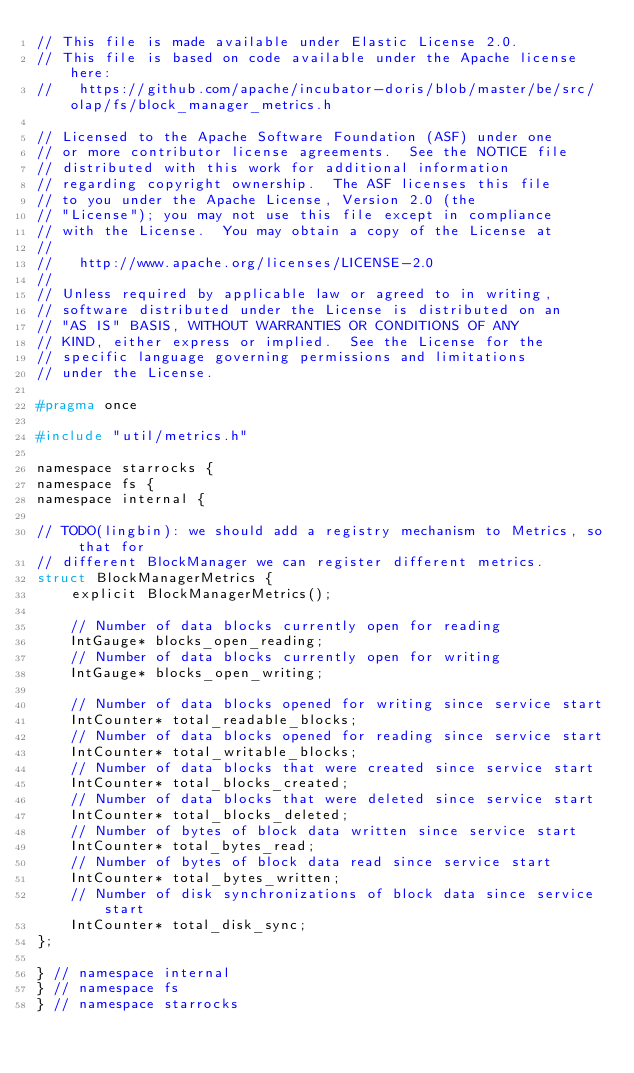<code> <loc_0><loc_0><loc_500><loc_500><_C_>// This file is made available under Elastic License 2.0.
// This file is based on code available under the Apache license here:
//   https://github.com/apache/incubator-doris/blob/master/be/src/olap/fs/block_manager_metrics.h

// Licensed to the Apache Software Foundation (ASF) under one
// or more contributor license agreements.  See the NOTICE file
// distributed with this work for additional information
// regarding copyright ownership.  The ASF licenses this file
// to you under the Apache License, Version 2.0 (the
// "License"); you may not use this file except in compliance
// with the License.  You may obtain a copy of the License at
//
//   http://www.apache.org/licenses/LICENSE-2.0
//
// Unless required by applicable law or agreed to in writing,
// software distributed under the License is distributed on an
// "AS IS" BASIS, WITHOUT WARRANTIES OR CONDITIONS OF ANY
// KIND, either express or implied.  See the License for the
// specific language governing permissions and limitations
// under the License.

#pragma once

#include "util/metrics.h"

namespace starrocks {
namespace fs {
namespace internal {

// TODO(lingbin): we should add a registry mechanism to Metrics, so that for
// different BlockManager we can register different metrics.
struct BlockManagerMetrics {
    explicit BlockManagerMetrics();

    // Number of data blocks currently open for reading
    IntGauge* blocks_open_reading;
    // Number of data blocks currently open for writing
    IntGauge* blocks_open_writing;

    // Number of data blocks opened for writing since service start
    IntCounter* total_readable_blocks;
    // Number of data blocks opened for reading since service start
    IntCounter* total_writable_blocks;
    // Number of data blocks that were created since service start
    IntCounter* total_blocks_created;
    // Number of data blocks that were deleted since service start
    IntCounter* total_blocks_deleted;
    // Number of bytes of block data written since service start
    IntCounter* total_bytes_read;
    // Number of bytes of block data read since service start
    IntCounter* total_bytes_written;
    // Number of disk synchronizations of block data since service start
    IntCounter* total_disk_sync;
};

} // namespace internal
} // namespace fs
} // namespace starrocks
</code> 